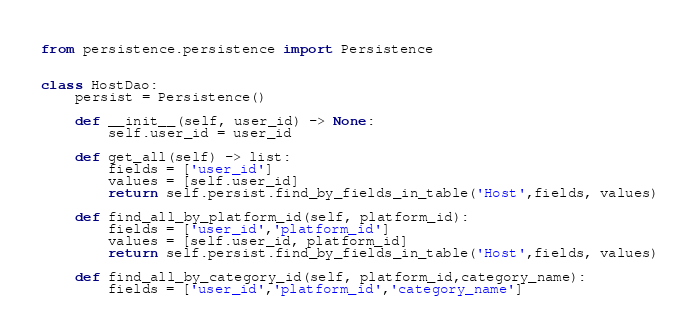Convert code to text. <code><loc_0><loc_0><loc_500><loc_500><_Python_>

from persistence.persistence import Persistence


class HostDao:
    persist = Persistence()

    def __init__(self, user_id) -> None:
        self.user_id = user_id

    def get_all(self) -> list:
        fields = ['user_id']
        values = [self.user_id]
        return self.persist.find_by_fields_in_table('Host',fields, values)

    def find_all_by_platform_id(self, platform_id):
        fields = ['user_id','platform_id']
        values = [self.user_id, platform_id]
        return self.persist.find_by_fields_in_table('Host',fields, values)
    
    def find_all_by_category_id(self, platform_id,category_name):
        fields = ['user_id','platform_id','category_name']</code> 